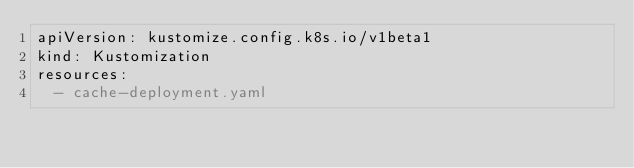<code> <loc_0><loc_0><loc_500><loc_500><_YAML_>apiVersion: kustomize.config.k8s.io/v1beta1
kind: Kustomization
resources:
  - cache-deployment.yaml</code> 